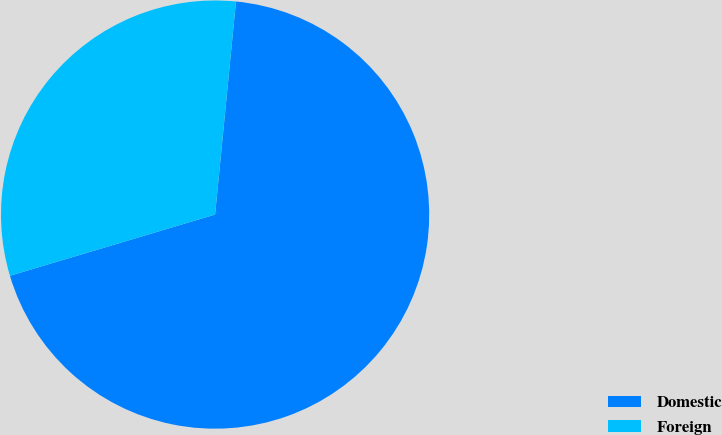Convert chart to OTSL. <chart><loc_0><loc_0><loc_500><loc_500><pie_chart><fcel>Domestic<fcel>Foreign<nl><fcel>68.83%<fcel>31.17%<nl></chart> 